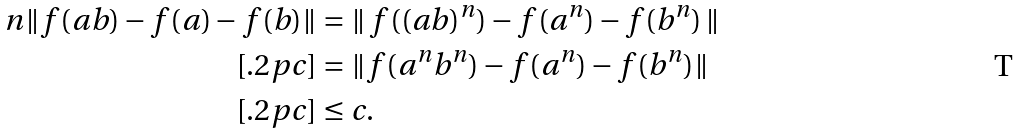<formula> <loc_0><loc_0><loc_500><loc_500>n \| f ( a b ) - f ( a ) - f ( b ) \| & = \| \, f ( ( a b ) ^ { n } ) - f ( a ^ { n } ) - f ( b ^ { n } ) \, \| \\ [ . 2 p c ] & = \| f ( a ^ { n } b ^ { n } ) - f ( a ^ { n } ) - f ( b ^ { n } ) \| \\ [ . 2 p c ] & \leq c .</formula> 